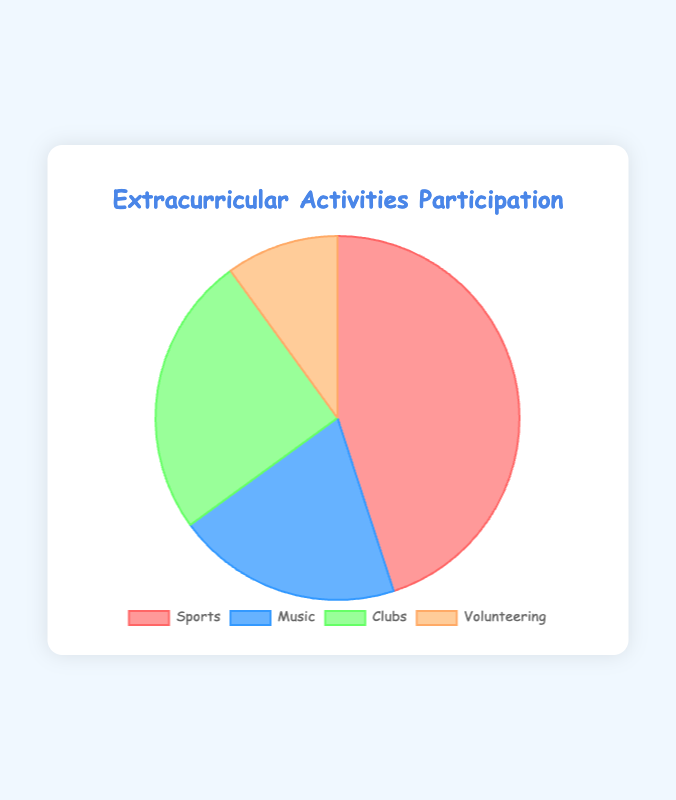Which extracurricular activity has the highest participation rate? According to the pie chart, Sports has the largest section of the pie, which represents its participation rate. By looking at the data provided, Sports is 45%, which is the highest among all activities.
Answer: Sports Which two extracurricular activities have a combined participation rate of 45%? To find this, we need to add the participation rates of any two activities. Music has 20% and Clubs has 25%. Adding these two rates together, we get 20% + 25% = 45%.
Answer: Music and Clubs How many times greater is the participation rate in Sports compared to Volunteering? The participation rate of Sports is 45%, and that of Volunteering is 10%. By dividing the Sports rate by the Volunteering rate, we get 45% ÷ 10% = 4.5, meaning Sports participation is 4.5 times greater than Volunteering.
Answer: 4.5 times Which activity has the smallest participation segment and what color is it in the pie chart? By looking at the pie chart, Volunteering has the smallest section. The corresponding color for Volunteering in the chart is light orange (or similar shade).
Answer: Volunteering, light orange If the total number of participants is 1000, how many more students participate in Clubs than in Volunteering? First, we find the difference in the participation rates of Clubs and Volunteering, which is 25% - 10% = 15%. For 1000 students, 15% of 1000 is calculated as (15/100) * 1000 = 150. This means 150 more students participate in Clubs than in Volunteering.
Answer: 150 What is the total participation rate of non-sports activities? To find this, we need to sum the rates for Music, Clubs, and Volunteering. The participation rates are 20%, 25%, and 10%, respectively. Adding these, 20% + 25% + 10% = 55%. The total rate for non-sports activities is 55%.
Answer: 55% Which two activities combined have a lower participation rate than Sports? We look at the participation rates. Music has 20% and Volunteering has 10%, which combined gives 20% + 10% = 30%. Since 30% is less than 45%, Music and Volunteering combined have a lower participation rate than Sports.
Answer: Music and Volunteering If the Music participation rate increased by 10%, would it exceed the Clubs participation rate? The current Music rate is 20%. If it increased by 10%, it would become 20% + 10% = 30%. The current Clubs rate is 25%. Since 30% is greater than 25%, the increased Music rate would exceed the Clubs rate.
Answer: Yes What is the average participation rate for all activities? To find the average participation rate, sum all the rates and divide by the number of activities. The rates are 45%, 20%, 25%, and 10%. The sum is 45% + 20% + 25% + 10% = 100%. Dividing by 4 activities, 100% / 4 = 25%.
Answer: 25% If the Volunteering rate doubled, how would its participation rate compare to Music? The current Volunteering rate is 10%. If it doubled, it would become 10% * 2 = 20%. Since the Music rate is also 20%, they would be equal.
Answer: Equal 